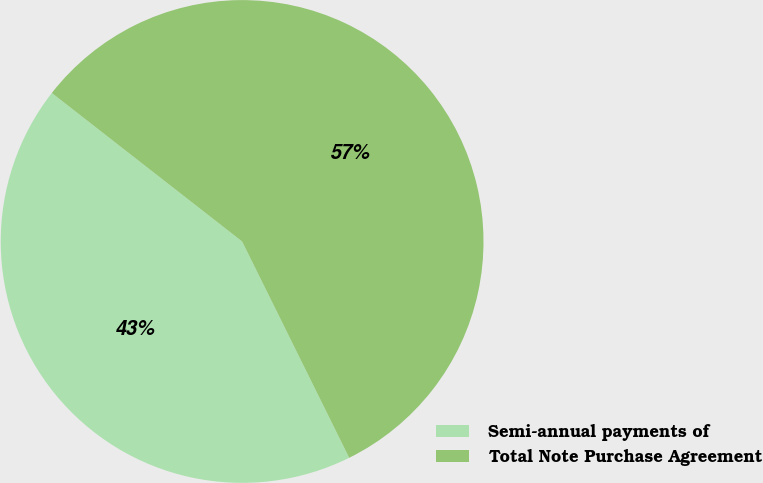Convert chart. <chart><loc_0><loc_0><loc_500><loc_500><pie_chart><fcel>Semi-annual payments of<fcel>Total Note Purchase Agreement<nl><fcel>42.86%<fcel>57.14%<nl></chart> 